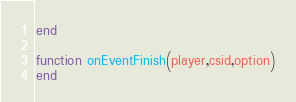Convert code to text. <code><loc_0><loc_0><loc_500><loc_500><_Lua_>end

function onEventFinish(player,csid,option)
end
</code> 